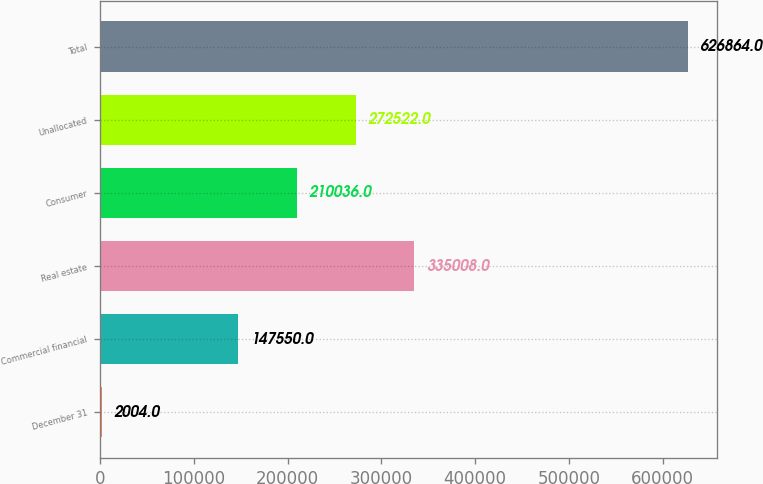<chart> <loc_0><loc_0><loc_500><loc_500><bar_chart><fcel>December 31<fcel>Commercial financial<fcel>Real estate<fcel>Consumer<fcel>Unallocated<fcel>Total<nl><fcel>2004<fcel>147550<fcel>335008<fcel>210036<fcel>272522<fcel>626864<nl></chart> 